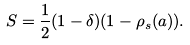<formula> <loc_0><loc_0><loc_500><loc_500>S = \frac { 1 } { 2 } ( 1 - \delta ) ( 1 - \rho _ { s } ( a ) ) .</formula> 